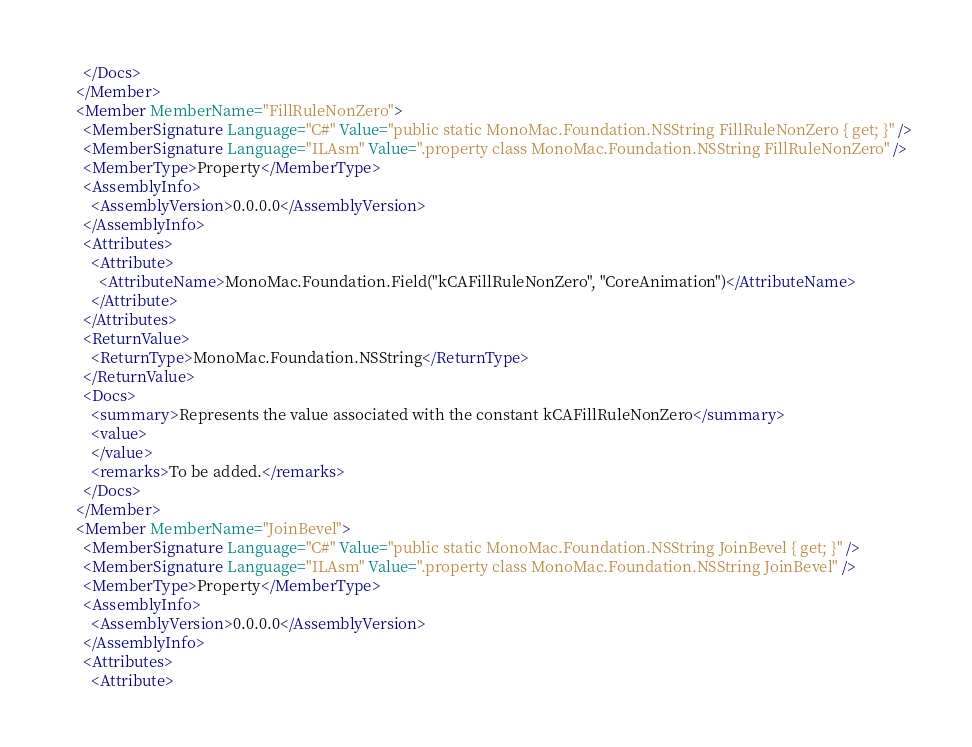Convert code to text. <code><loc_0><loc_0><loc_500><loc_500><_XML_>      </Docs>
    </Member>
    <Member MemberName="FillRuleNonZero">
      <MemberSignature Language="C#" Value="public static MonoMac.Foundation.NSString FillRuleNonZero { get; }" />
      <MemberSignature Language="ILAsm" Value=".property class MonoMac.Foundation.NSString FillRuleNonZero" />
      <MemberType>Property</MemberType>
      <AssemblyInfo>
        <AssemblyVersion>0.0.0.0</AssemblyVersion>
      </AssemblyInfo>
      <Attributes>
        <Attribute>
          <AttributeName>MonoMac.Foundation.Field("kCAFillRuleNonZero", "CoreAnimation")</AttributeName>
        </Attribute>
      </Attributes>
      <ReturnValue>
        <ReturnType>MonoMac.Foundation.NSString</ReturnType>
      </ReturnValue>
      <Docs>
        <summary>Represents the value associated with the constant kCAFillRuleNonZero</summary>
        <value>
        </value>
        <remarks>To be added.</remarks>
      </Docs>
    </Member>
    <Member MemberName="JoinBevel">
      <MemberSignature Language="C#" Value="public static MonoMac.Foundation.NSString JoinBevel { get; }" />
      <MemberSignature Language="ILAsm" Value=".property class MonoMac.Foundation.NSString JoinBevel" />
      <MemberType>Property</MemberType>
      <AssemblyInfo>
        <AssemblyVersion>0.0.0.0</AssemblyVersion>
      </AssemblyInfo>
      <Attributes>
        <Attribute></code> 